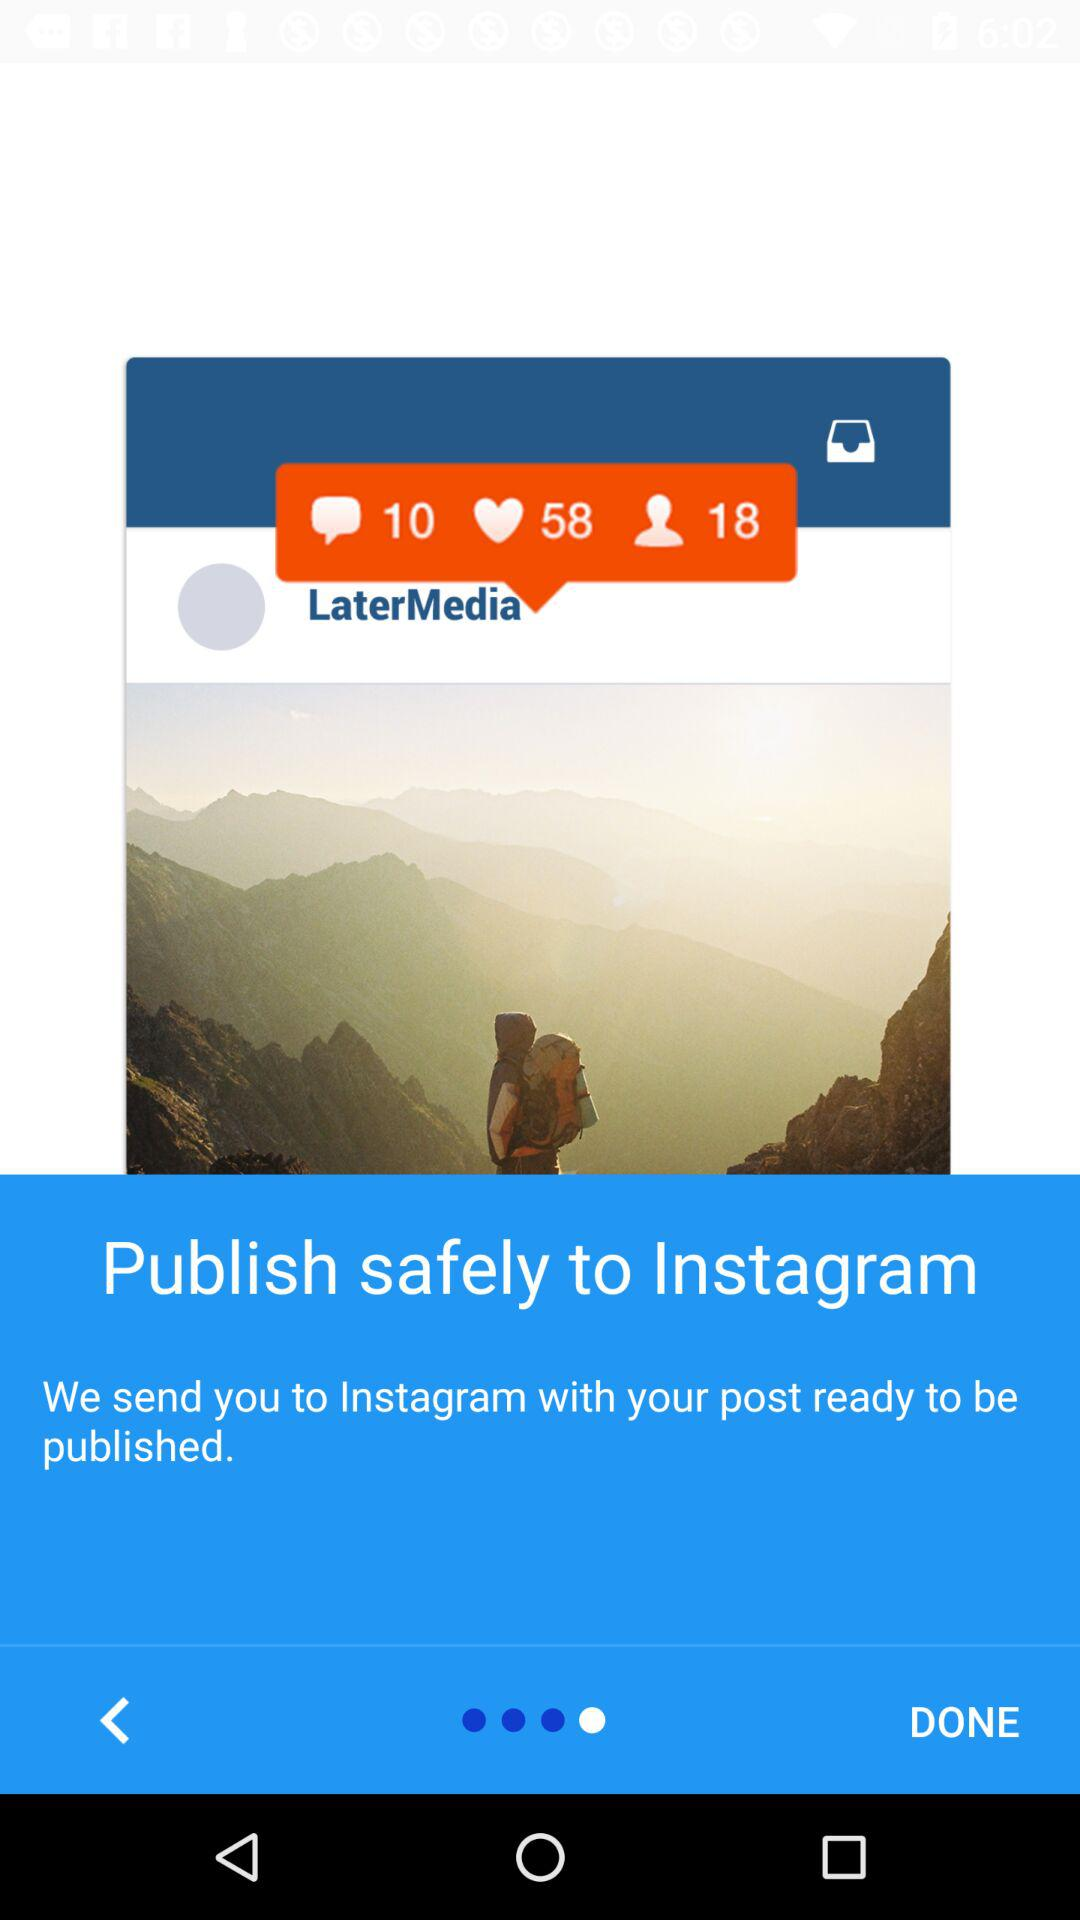How many more likes does the post have than comments?
Answer the question using a single word or phrase. 48 